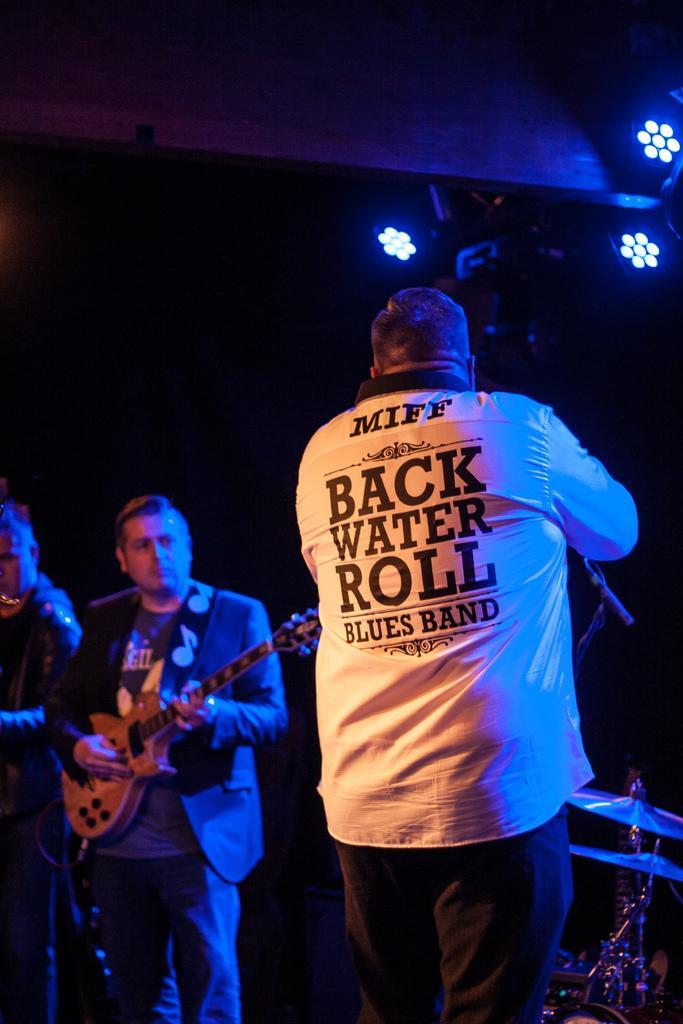Can you describe this image briefly? there are three persons playing musical instruments 